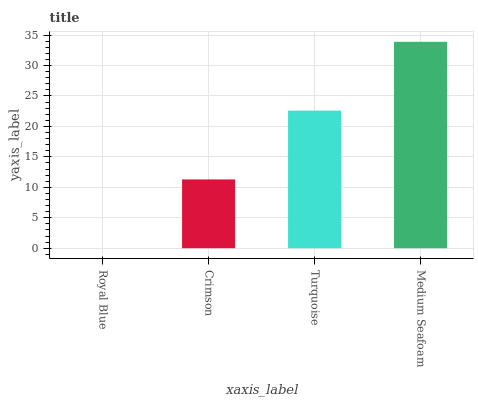Is Crimson the minimum?
Answer yes or no. No. Is Crimson the maximum?
Answer yes or no. No. Is Crimson greater than Royal Blue?
Answer yes or no. Yes. Is Royal Blue less than Crimson?
Answer yes or no. Yes. Is Royal Blue greater than Crimson?
Answer yes or no. No. Is Crimson less than Royal Blue?
Answer yes or no. No. Is Turquoise the high median?
Answer yes or no. Yes. Is Crimson the low median?
Answer yes or no. Yes. Is Medium Seafoam the high median?
Answer yes or no. No. Is Medium Seafoam the low median?
Answer yes or no. No. 